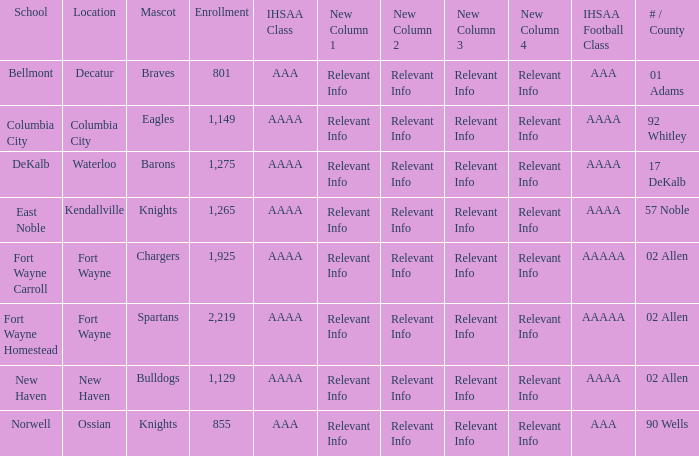What school has a mascot of the spartans with an AAAA IHSAA class and more than 1,275 enrolled? Fort Wayne Homestead. 